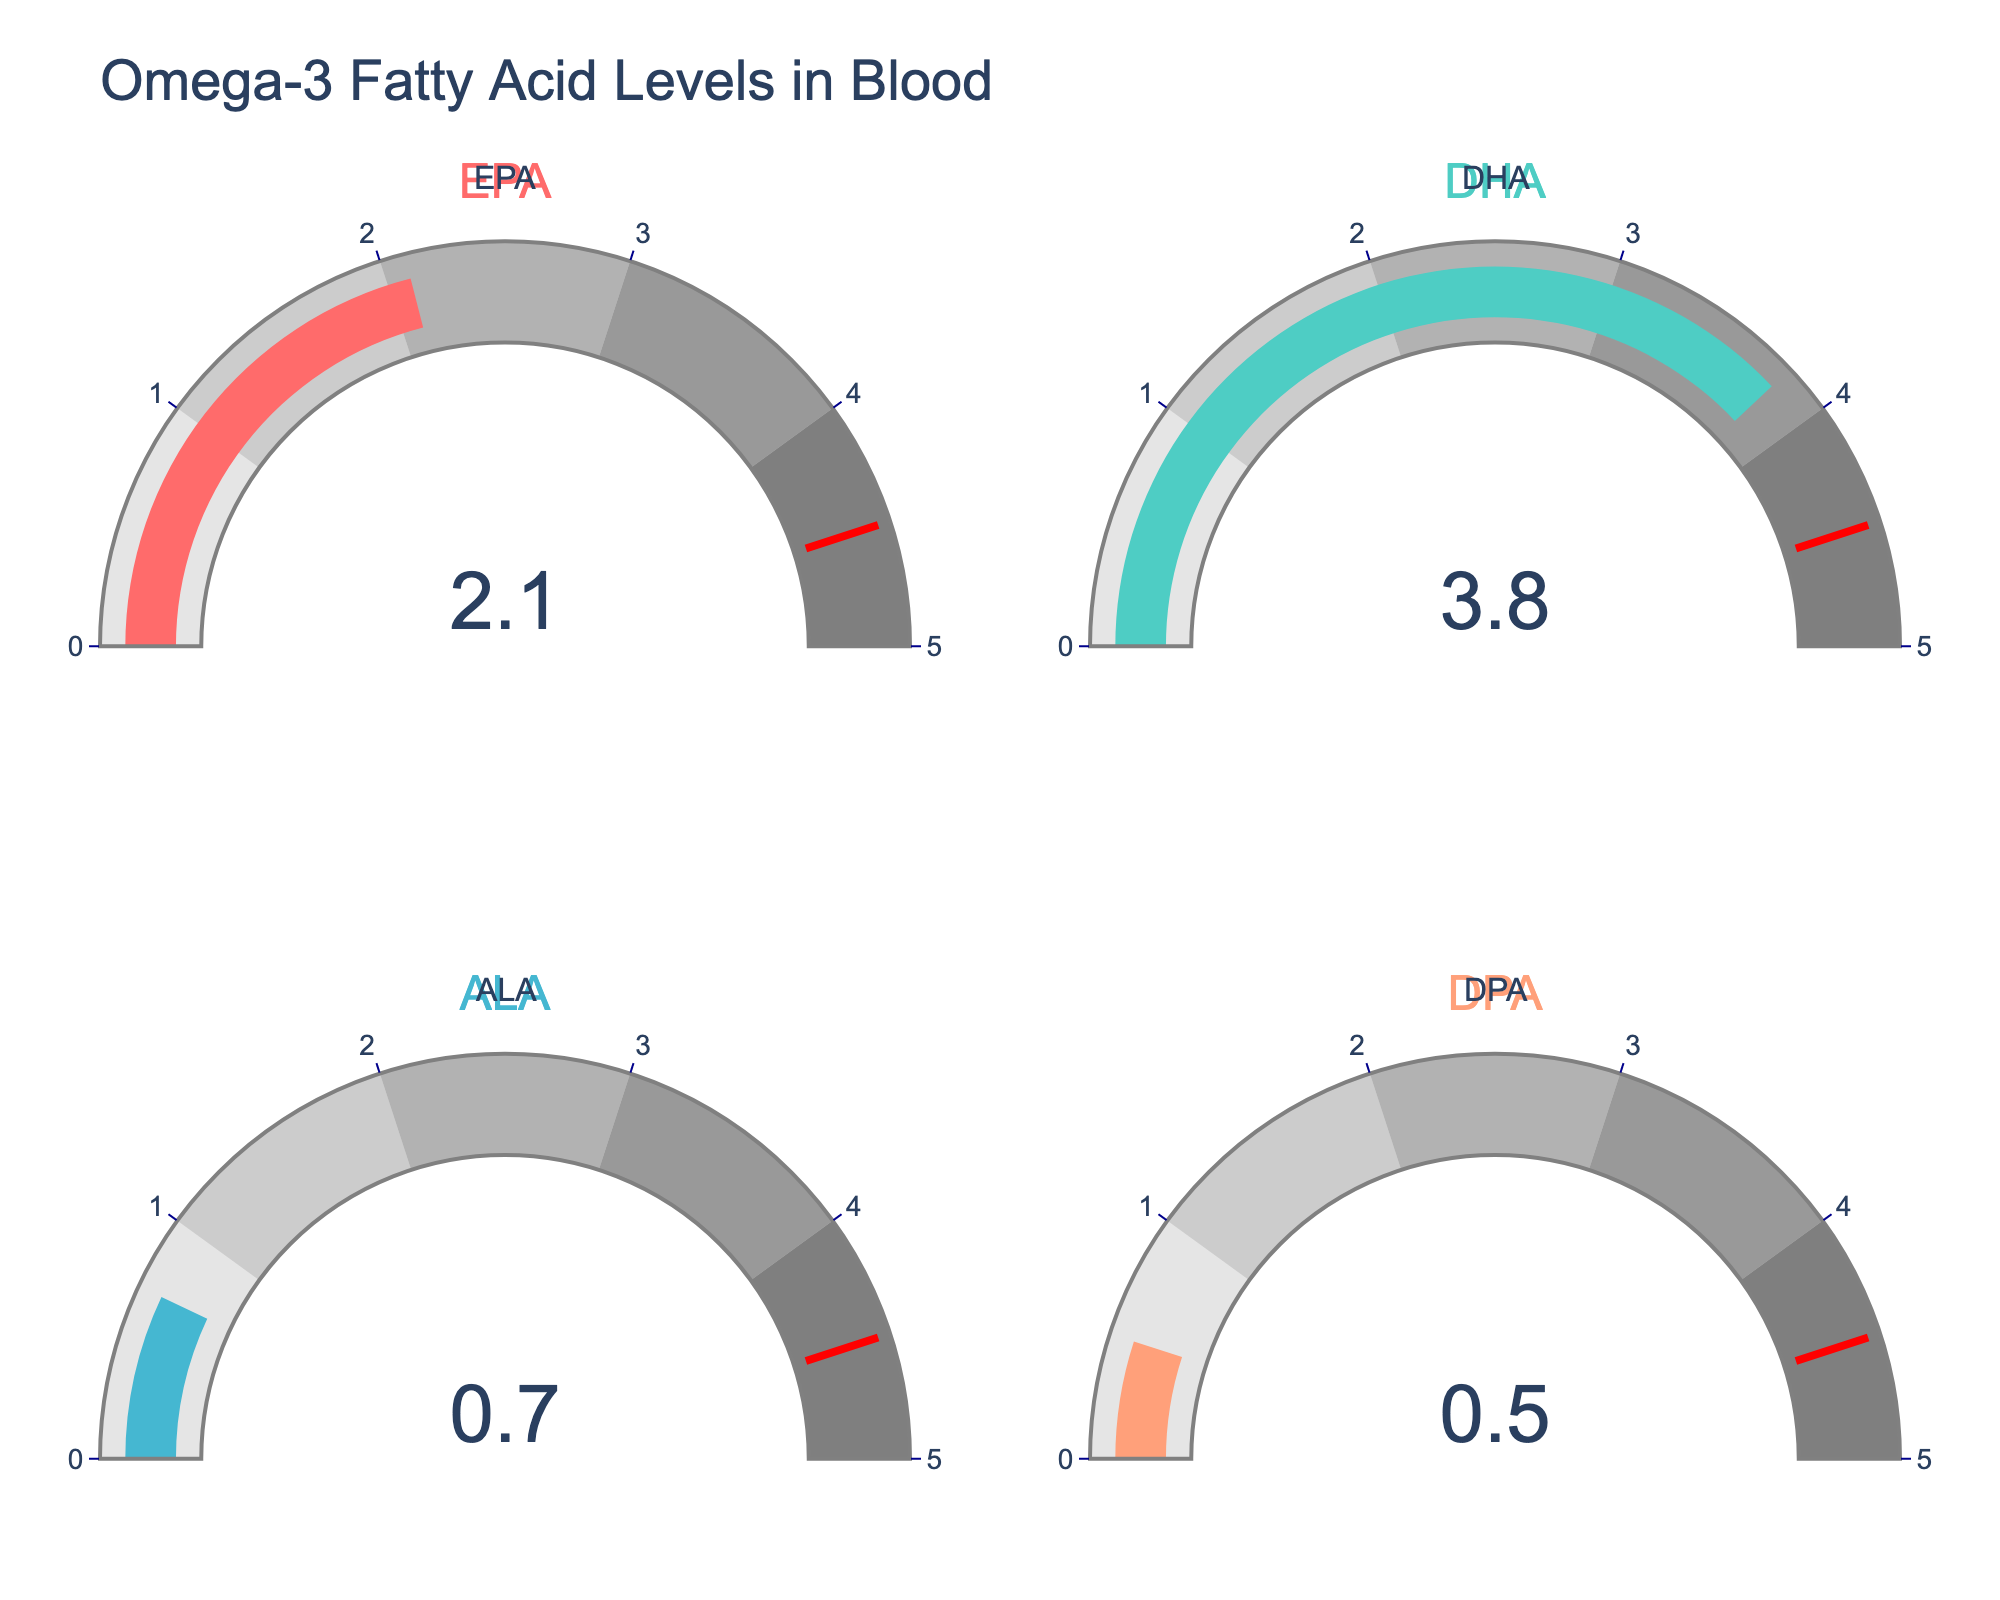what is the blood level percentage of EPA? Look at the gauge chart labeled EPA. The number displayed on the gauge is the blood level percentage.
Answer: 2.1% Which Omega-3 type has the highest blood level percentage? Compare the numbers on each gauge chart. The highest number corresponds to the Omega-3 type with the highest blood level percentage.
Answer: DHA What's the total blood level percentage of DHA and EPA? Add the blood level percentages of DHA and EPA from their respective gauge charts. 3.8% + 2.1% = 5.9%
Answer: 5.9% Is the blood level percentage of ALA less than that of DPA? Compare the numbers on the gauge charts for ALA and DPA. ALA shows 0.7%, and DPA shows 0.5%. 0.7% is not less than 0.5%.
Answer: No What's the difference in blood level percentage between the highest and the lowest Omega-3 types? Identify the highest (DHA at 3.8%) and the lowest (DPA at 0.5%) values from the gauge charts. Subtract the lowest from the highest: 3.8% - 0.5% = 3.3%
Answer: 3.3% How does the blood level percentage of EPA compare to the overall average percentage of all Omega-3 types? First, find the average blood level percentage: (2.1% + 3.8% + 0.7% + 0.5%) / 4 = 1.775%. Then compare EPA's percentage (2.1%) to this average. 2.1% is greater than 1.775%.
Answer: Greater Do any of the Omega-3 types exceed the threshold value indicated on the gauges? Check each gauge to see if the value exceeds the threshold marked at 4.5%. None of the values displayed on the gauges (2.1%, 3.8%, 0.7%, 0.5%) exceed 4.5%.
Answer: No What's the combined blood level percentage of DPA and ALA? Add the blood level percentages of DPA and ALA from their respective gauge charts. 0.5% + 0.7% = 1.2%
Answer: 1.2% Which Omega-3 type has the closest blood level percentage to the threshold value? The threshold value is indicated as 4.5% on the gauges. Compare each Omega-3 type's blood level percentage to this threshold and identify the closest: DHA at 3.8% is closest to 4.5%.
Answer: DHA What's the average blood level percentage of ALA and DPA? Add the blood level percentages of ALA and DPA, then divide by 2. (0.7% + 0.5%) / 2 = 0.6%
Answer: 0.6% 